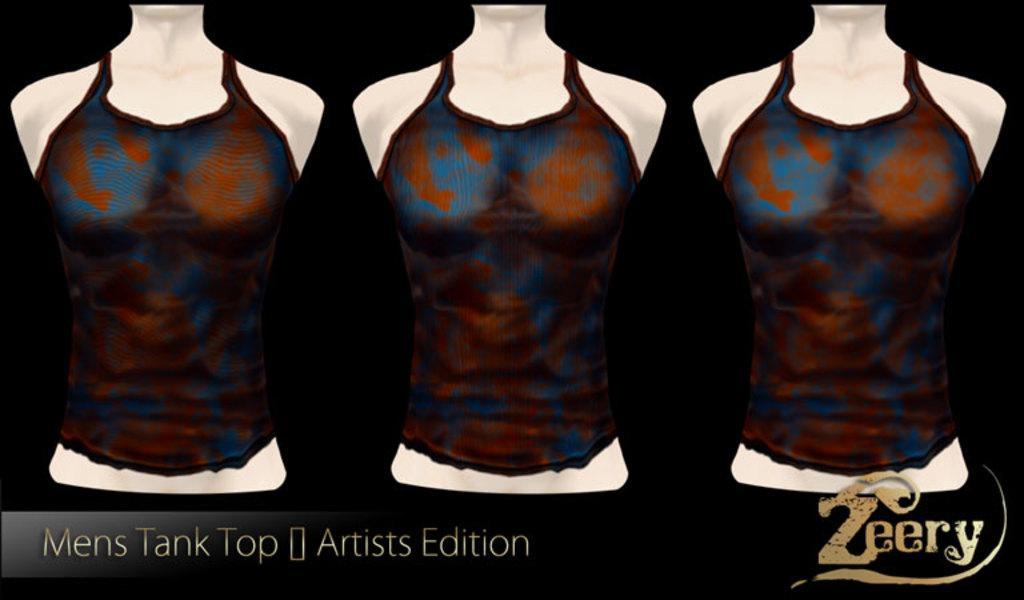Describe this image in one or two sentences. In this picture we can see mannequins. 